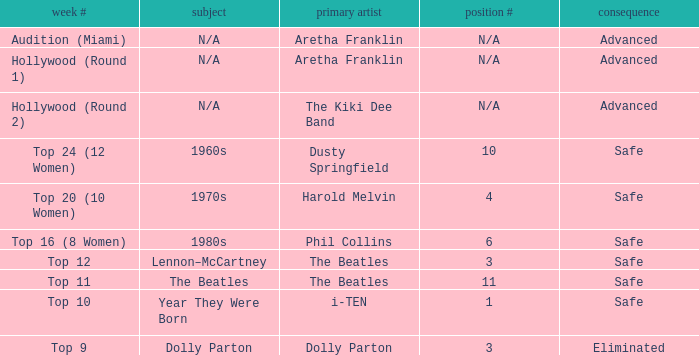What is the week number that has Dolly Parton as the theme? Top 9. 